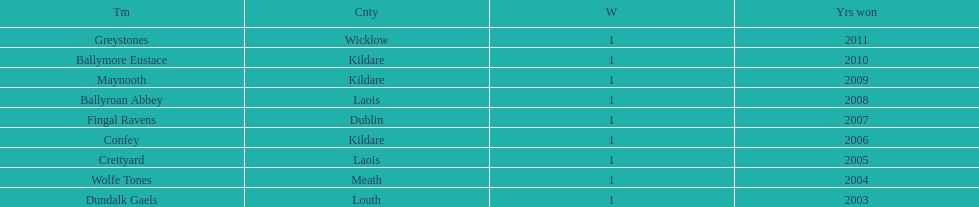Which county holds the record for the most wins? Kildare. 